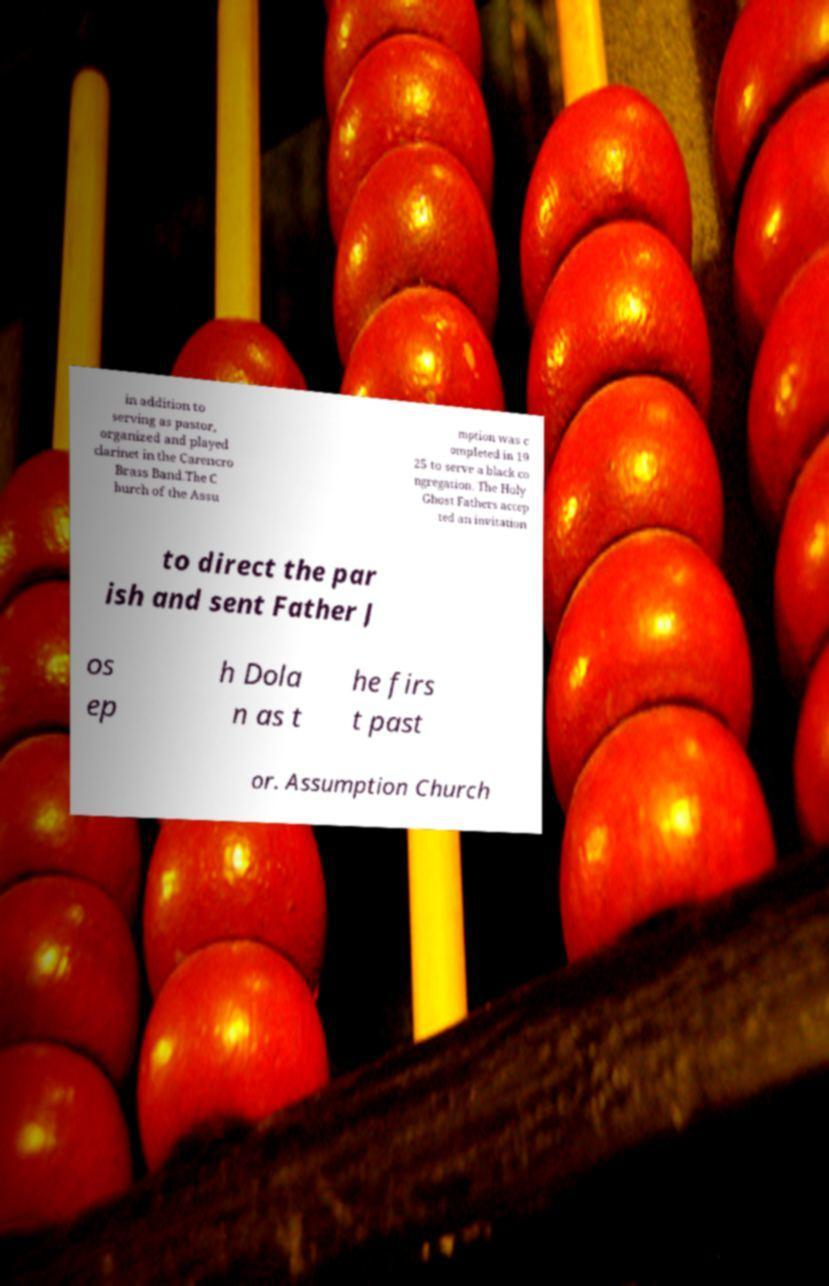Can you read and provide the text displayed in the image?This photo seems to have some interesting text. Can you extract and type it out for me? in addition to serving as pastor, organized and played clarinet in the Carencro Brass Band.The C hurch of the Assu mption was c ompleted in 19 25 to serve a black co ngregation. The Holy Ghost Fathers accep ted an invitation to direct the par ish and sent Father J os ep h Dola n as t he firs t past or. Assumption Church 